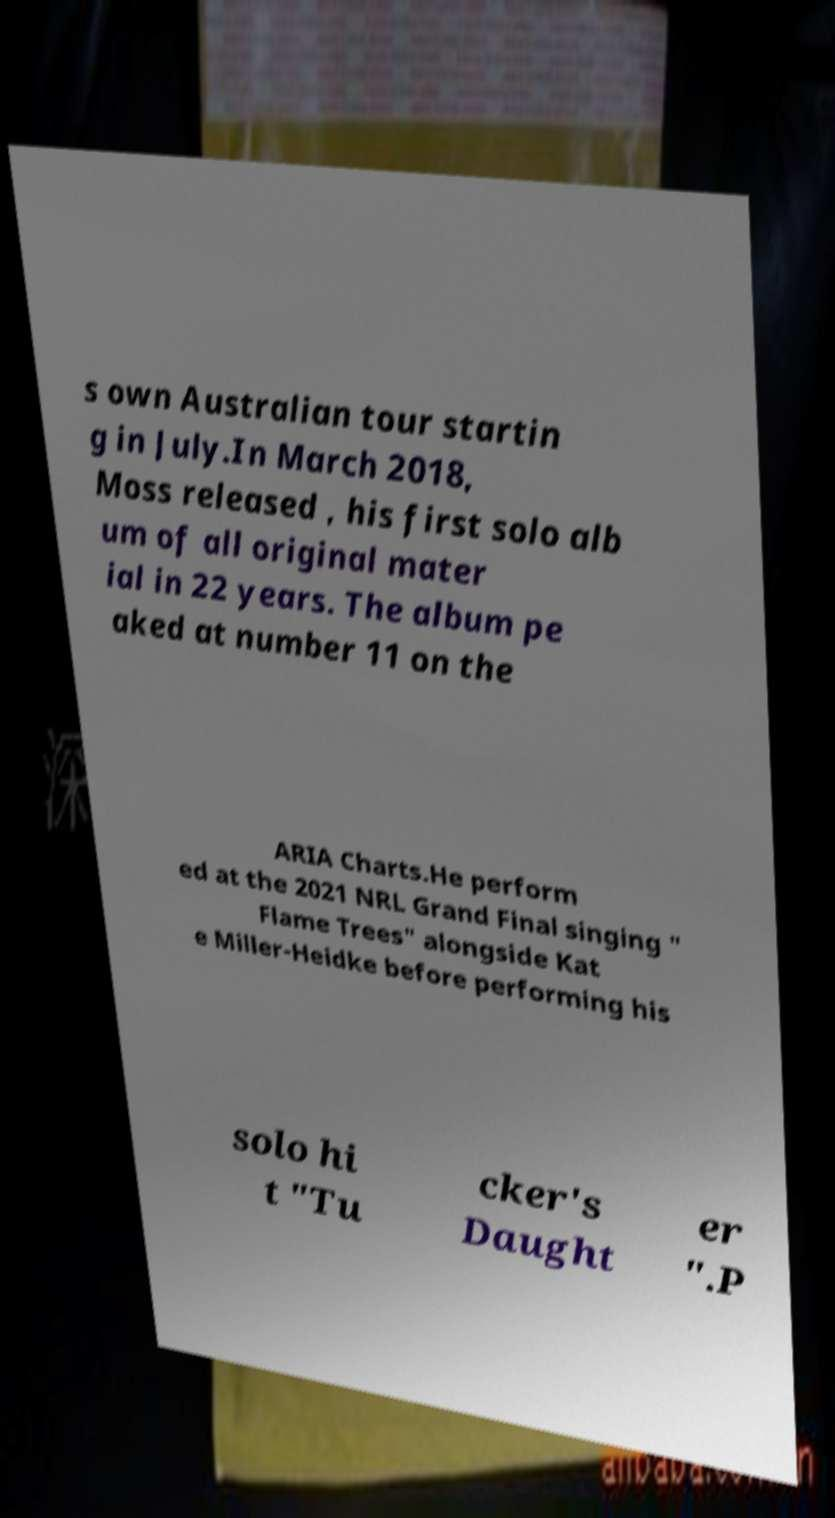Can you read and provide the text displayed in the image?This photo seems to have some interesting text. Can you extract and type it out for me? s own Australian tour startin g in July.In March 2018, Moss released , his first solo alb um of all original mater ial in 22 years. The album pe aked at number 11 on the ARIA Charts.He perform ed at the 2021 NRL Grand Final singing " Flame Trees" alongside Kat e Miller-Heidke before performing his solo hi t "Tu cker's Daught er ".P 